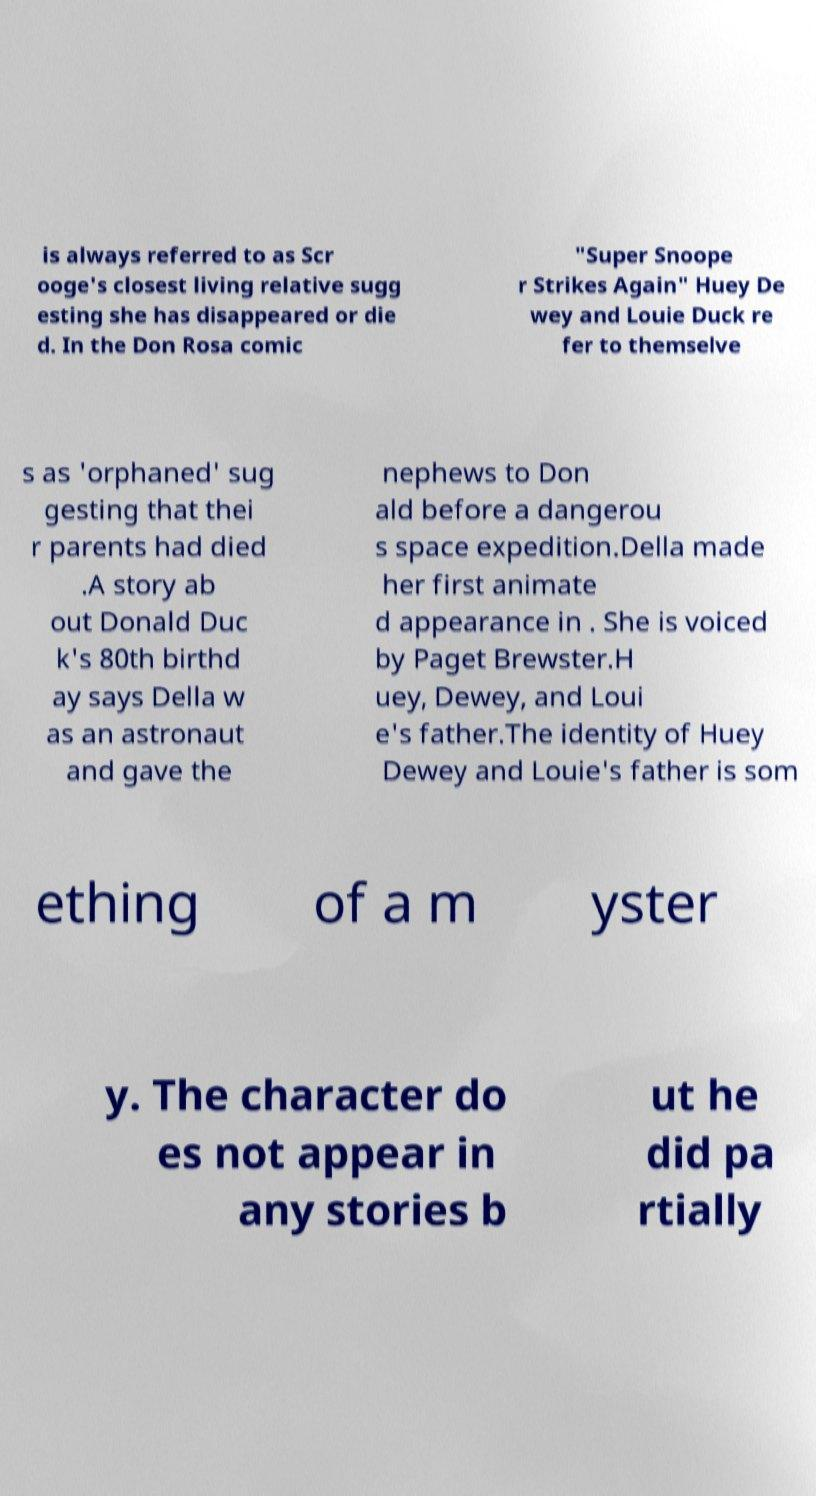Could you extract and type out the text from this image? is always referred to as Scr ooge's closest living relative sugg esting she has disappeared or die d. In the Don Rosa comic "Super Snoope r Strikes Again" Huey De wey and Louie Duck re fer to themselve s as 'orphaned' sug gesting that thei r parents had died .A story ab out Donald Duc k's 80th birthd ay says Della w as an astronaut and gave the nephews to Don ald before a dangerou s space expedition.Della made her first animate d appearance in . She is voiced by Paget Brewster.H uey, Dewey, and Loui e's father.The identity of Huey Dewey and Louie's father is som ething of a m yster y. The character do es not appear in any stories b ut he did pa rtially 